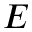<formula> <loc_0><loc_0><loc_500><loc_500>E</formula> 